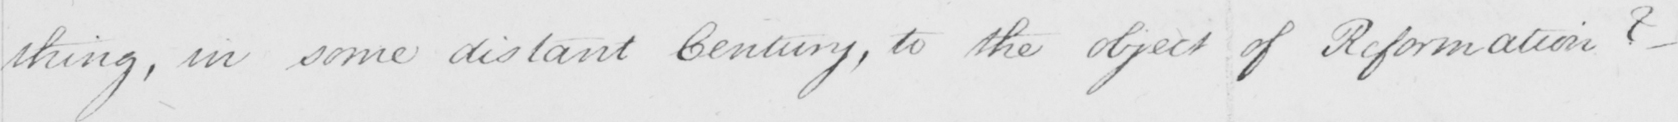What does this handwritten line say? thing , in some distant Century , to the object of Reformation ?   _ 